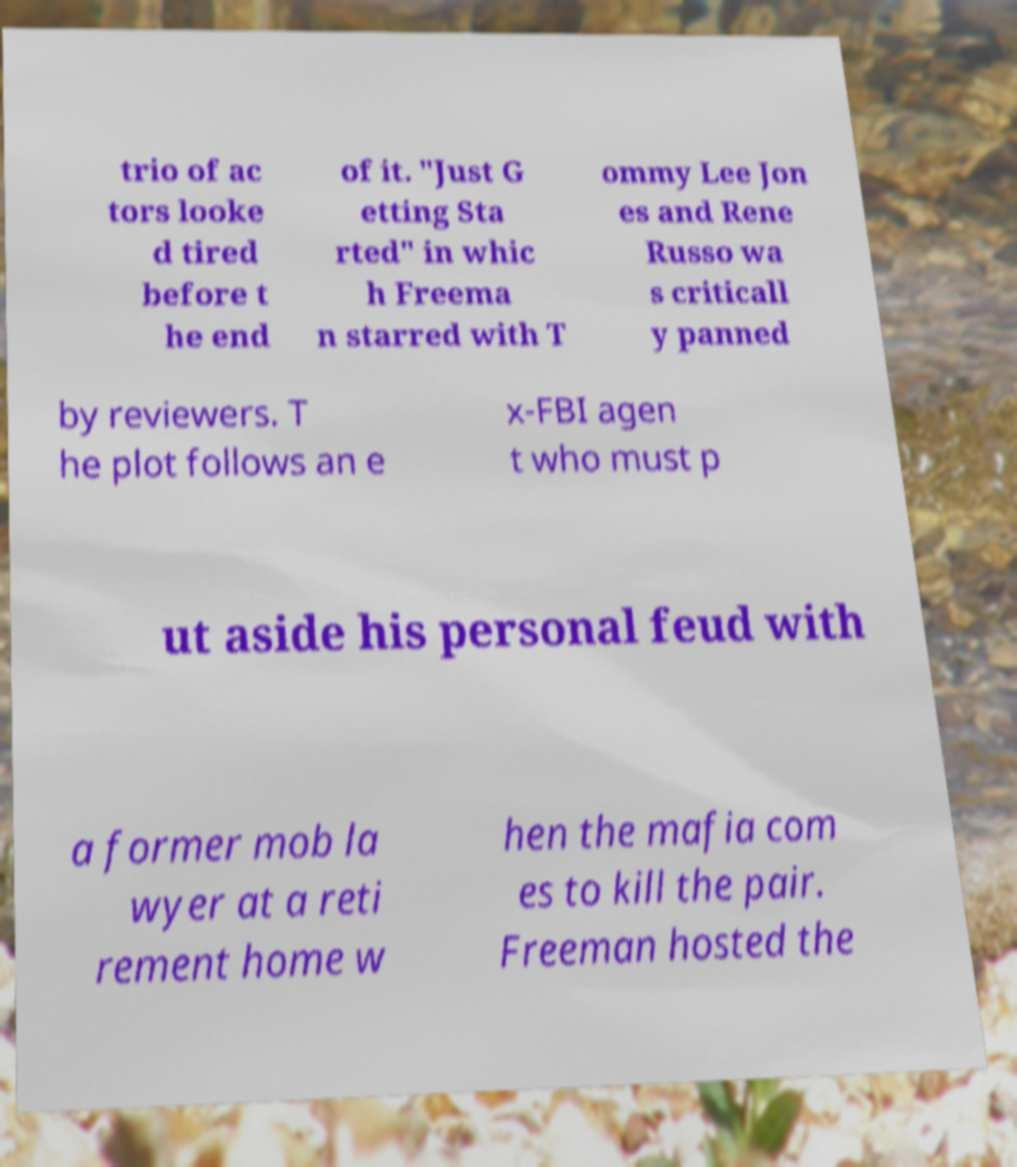Please read and relay the text visible in this image. What does it say? trio of ac tors looke d tired before t he end of it. "Just G etting Sta rted" in whic h Freema n starred with T ommy Lee Jon es and Rene Russo wa s criticall y panned by reviewers. T he plot follows an e x-FBI agen t who must p ut aside his personal feud with a former mob la wyer at a reti rement home w hen the mafia com es to kill the pair. Freeman hosted the 